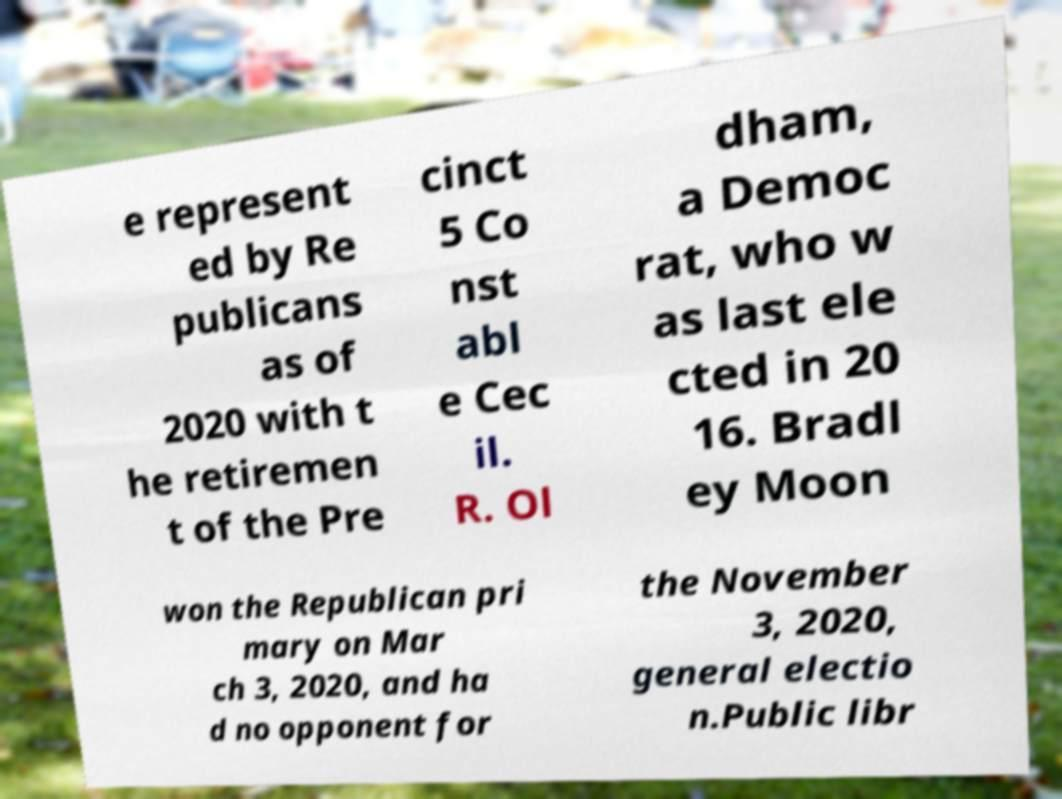There's text embedded in this image that I need extracted. Can you transcribe it verbatim? e represent ed by Re publicans as of 2020 with t he retiremen t of the Pre cinct 5 Co nst abl e Cec il. R. Ol dham, a Democ rat, who w as last ele cted in 20 16. Bradl ey Moon won the Republican pri mary on Mar ch 3, 2020, and ha d no opponent for the November 3, 2020, general electio n.Public libr 